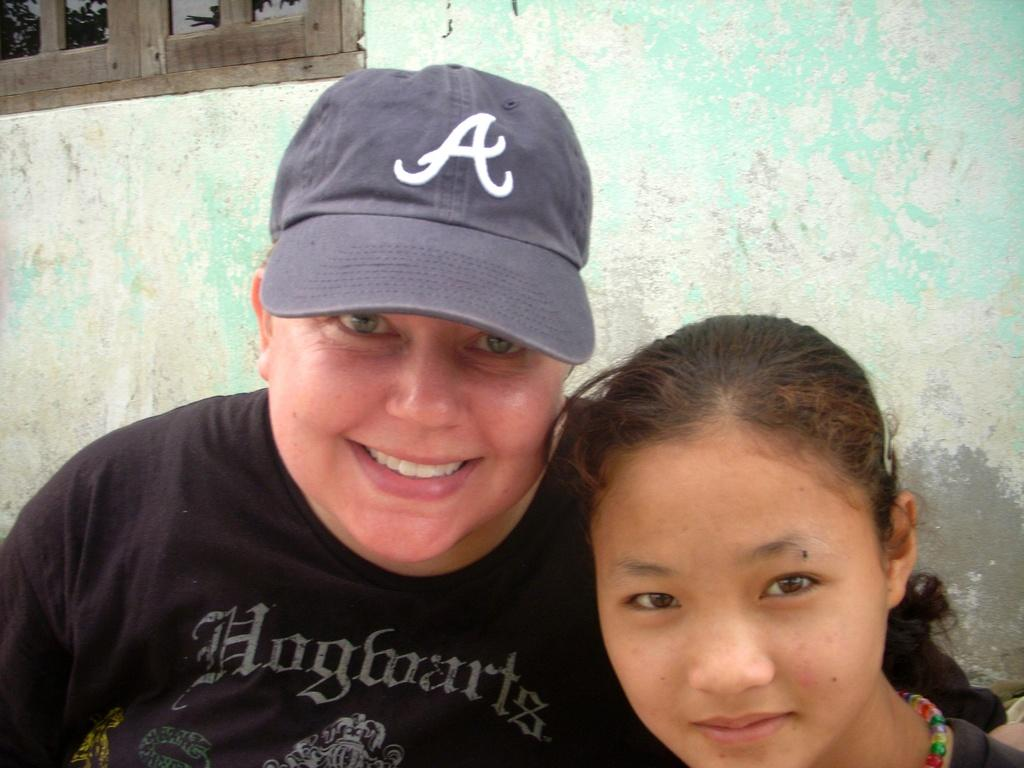How many people are visible in the image? There are two persons in the front of the image. What can be seen in the background of the image? There is a wall in the background of the image. Where is the window located in the image? There is a window at the left top of the image. What is the person on the left side wearing? The person on the left side is wearing a cap. Can you see any trains passing by in the image? No, there are no trains visible in the image. Is there a swing or park shown in the image? No, there is no swing or park present in the image. 